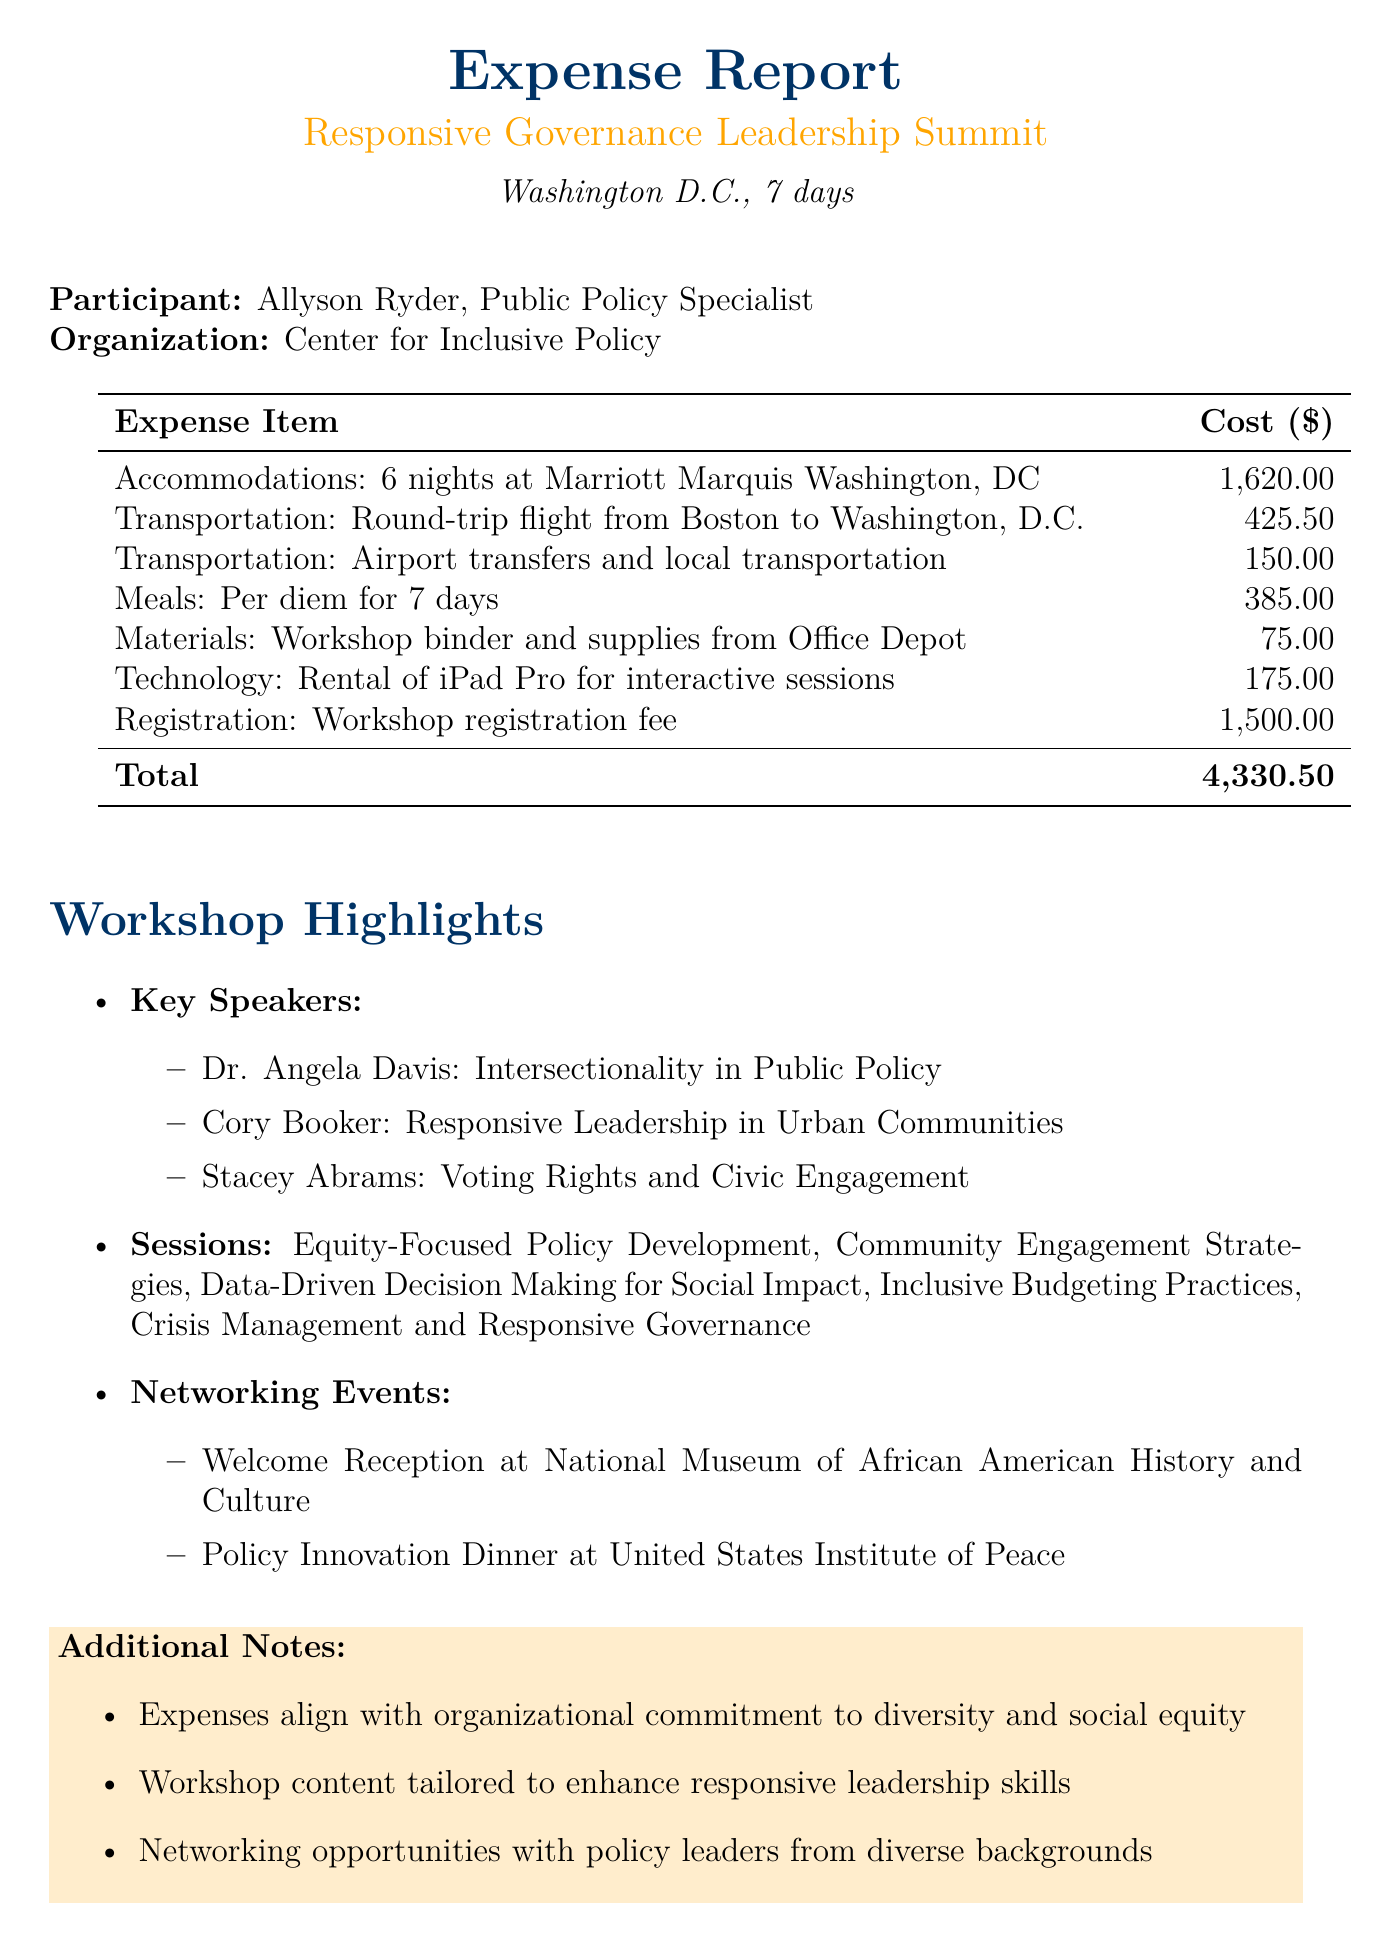what is the title of the workshop? The workshop title is clearly stated in the document as "Responsive Governance Leadership Summit."
Answer: Responsive Governance Leadership Summit how many nights of accommodations were billed? The document mentions 6 nights of accommodations at the Marriott Marquis Washington, DC.
Answer: 6 nights what is the total cost of the expenses reported? The total cost is found at the end of the expense items table, which sums up to $4,330.50.
Answer: 4,330.50 who is the participant named in the document? The document identifies Allyson Ryder as the participant.
Answer: Allyson Ryder what is one topic covered by a key speaker? The document lists various topics addressed by speakers; one is "Intersectionality in Public Policy."
Answer: Intersectionality in Public Policy how many networking events were mentioned? The document lists 2 networking events, specifically the Welcome Reception and Policy Innovation Dinner.
Answer: 2 what type of workshop materials were purchased? The expense report describes the materials as "Workshop binder and supplies from Office Depot."
Answer: Workshop binder and supplies from Office Depot which location hosted the Welcome Reception? The document specifies that the Welcome Reception took place at the National Museum of African American History and Culture.
Answer: National Museum of African American History and Culture 